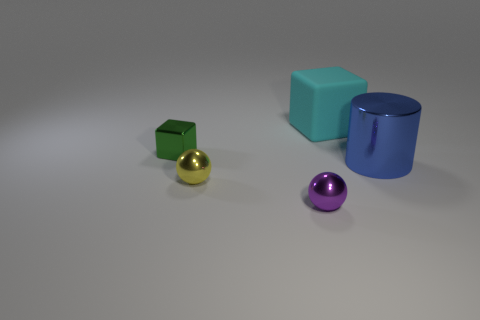There is a metal block; is its color the same as the large object that is behind the big cylinder?
Offer a very short reply. No. How many other objects are the same color as the large rubber block?
Offer a terse response. 0. Are there fewer big cyan rubber blocks than small things?
Your response must be concise. Yes. How many small yellow balls are behind the block that is to the right of the thing that is on the left side of the yellow ball?
Offer a very short reply. 0. What size is the shiny object that is behind the blue metal object?
Your answer should be very brief. Small. Does the object in front of the yellow metallic ball have the same shape as the blue shiny object?
Your answer should be very brief. No. There is another object that is the same shape as the large cyan matte thing; what is its material?
Your answer should be very brief. Metal. Is there any other thing that has the same size as the cyan thing?
Make the answer very short. Yes. Is there a yellow metal sphere?
Give a very brief answer. Yes. What material is the big object in front of the big thing that is on the left side of the big object in front of the cyan cube made of?
Your answer should be compact. Metal. 